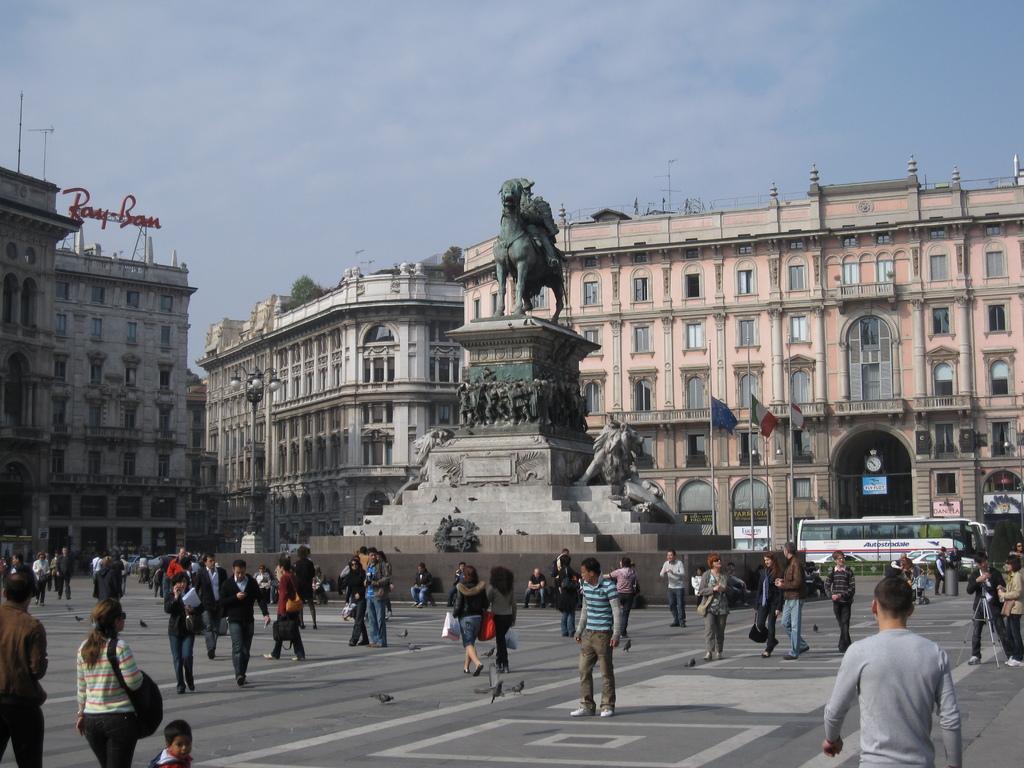Could you give a brief overview of what you see in this image? In this image I can see at the bottom many people are working on the road. In the middle there is the statue, at the back side there are very big buildings. At the top it is the sky. 